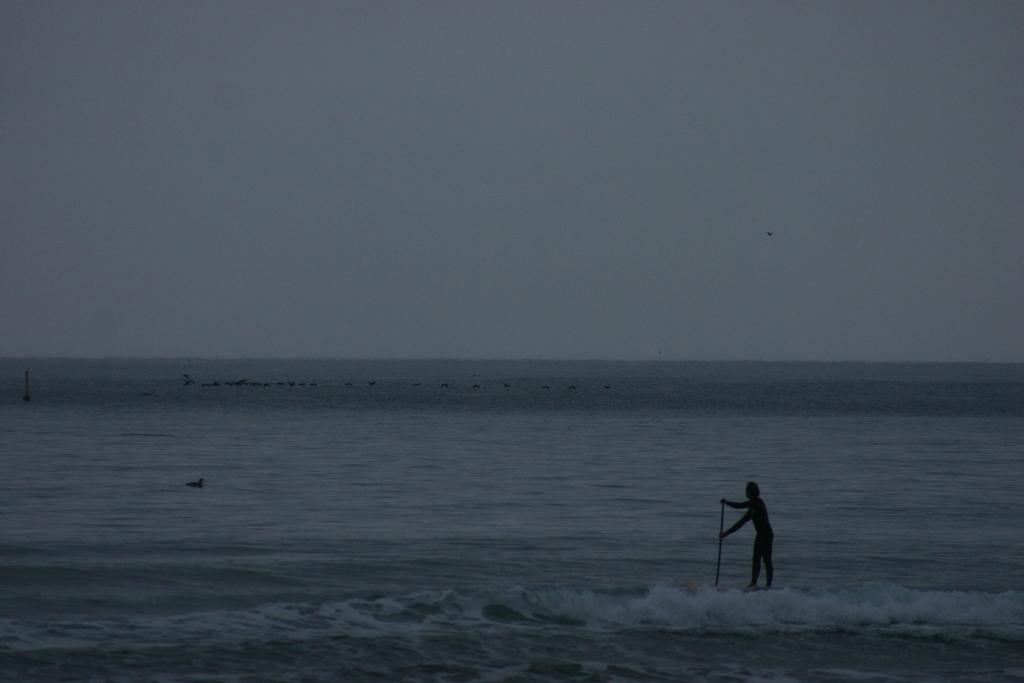What is present at the bottom of the image? There is water at the bottom of the image. What is happening in the foreground of the image? There is a person holding an object in the foreground. Can you describe the background of the image? There is water visible in the background of the image. What is visible at the top of the image? The sky is visible at the top of the image. What type of rock is the person's father working on in the image? There is no rock or person's father present in the image. What type of work is the person doing in the image? The image does not provide information about the person's work or occupation. 